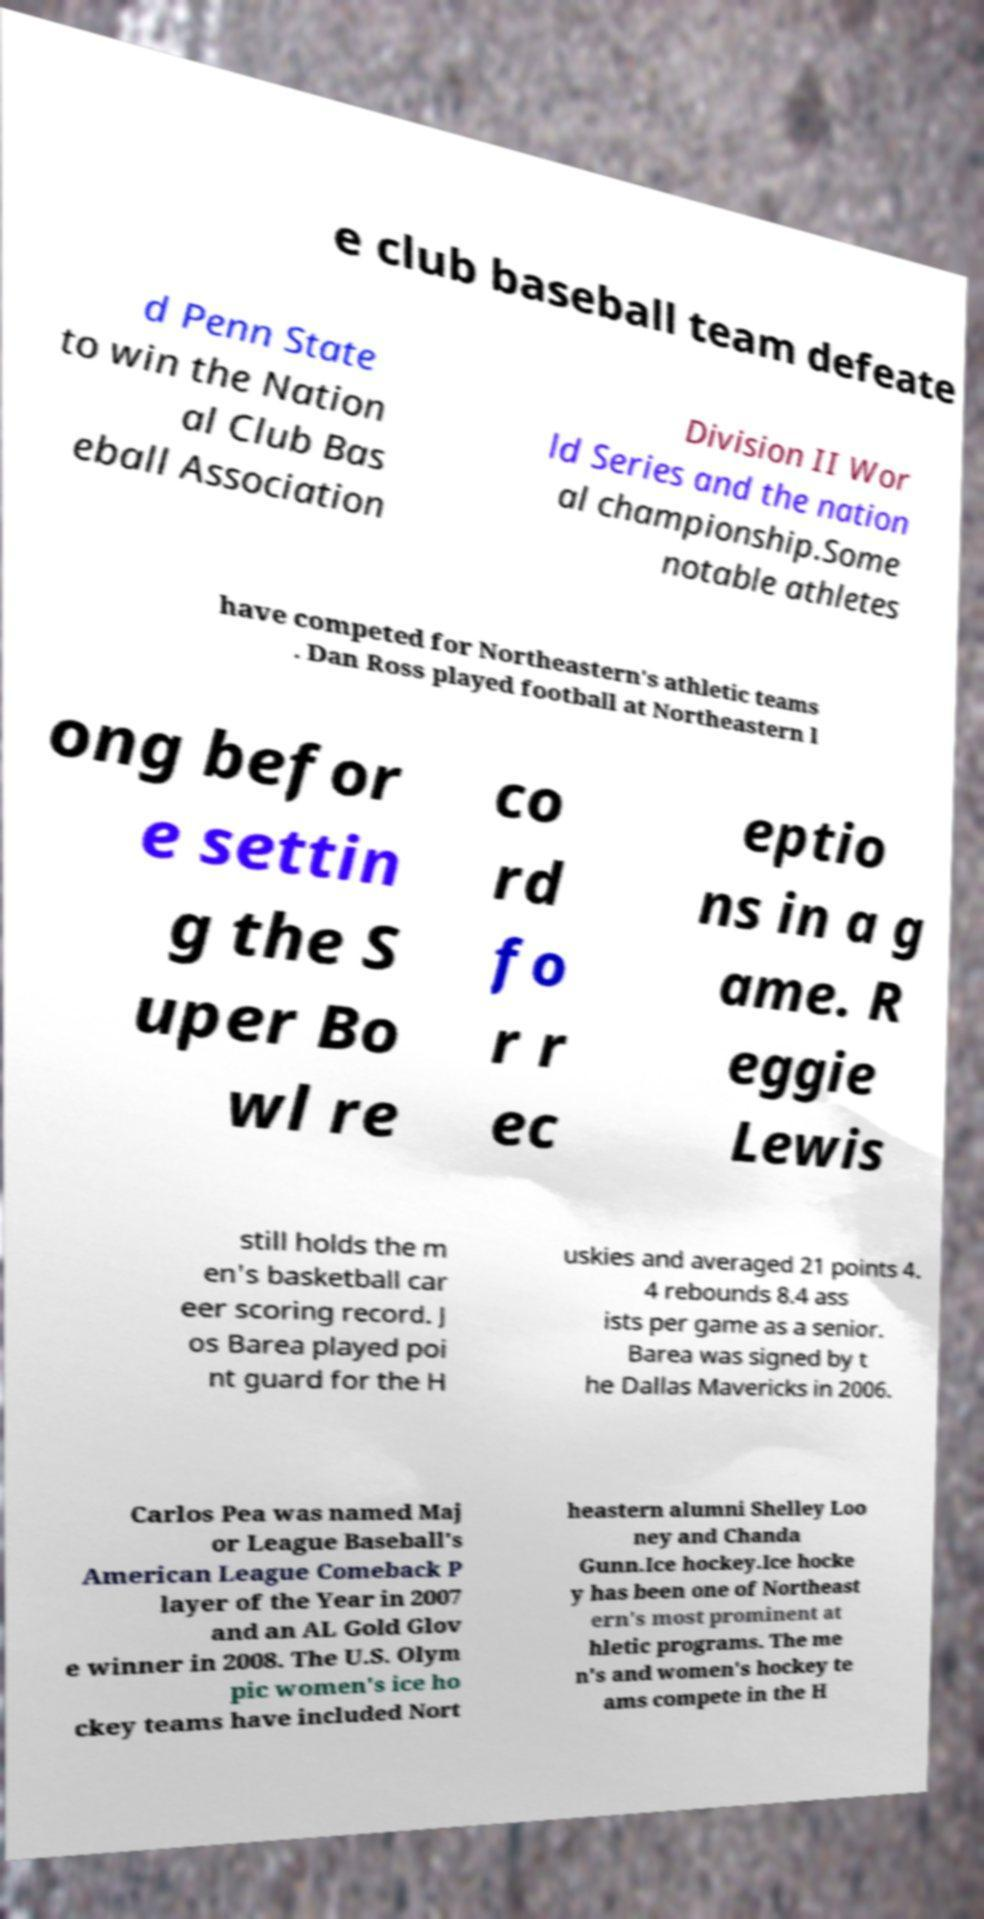Could you extract and type out the text from this image? e club baseball team defeate d Penn State to win the Nation al Club Bas eball Association Division II Wor ld Series and the nation al championship.Some notable athletes have competed for Northeastern's athletic teams . Dan Ross played football at Northeastern l ong befor e settin g the S uper Bo wl re co rd fo r r ec eptio ns in a g ame. R eggie Lewis still holds the m en's basketball car eer scoring record. J os Barea played poi nt guard for the H uskies and averaged 21 points 4. 4 rebounds 8.4 ass ists per game as a senior. Barea was signed by t he Dallas Mavericks in 2006. Carlos Pea was named Maj or League Baseball's American League Comeback P layer of the Year in 2007 and an AL Gold Glov e winner in 2008. The U.S. Olym pic women's ice ho ckey teams have included Nort heastern alumni Shelley Loo ney and Chanda Gunn.Ice hockey.Ice hocke y has been one of Northeast ern's most prominent at hletic programs. The me n's and women's hockey te ams compete in the H 